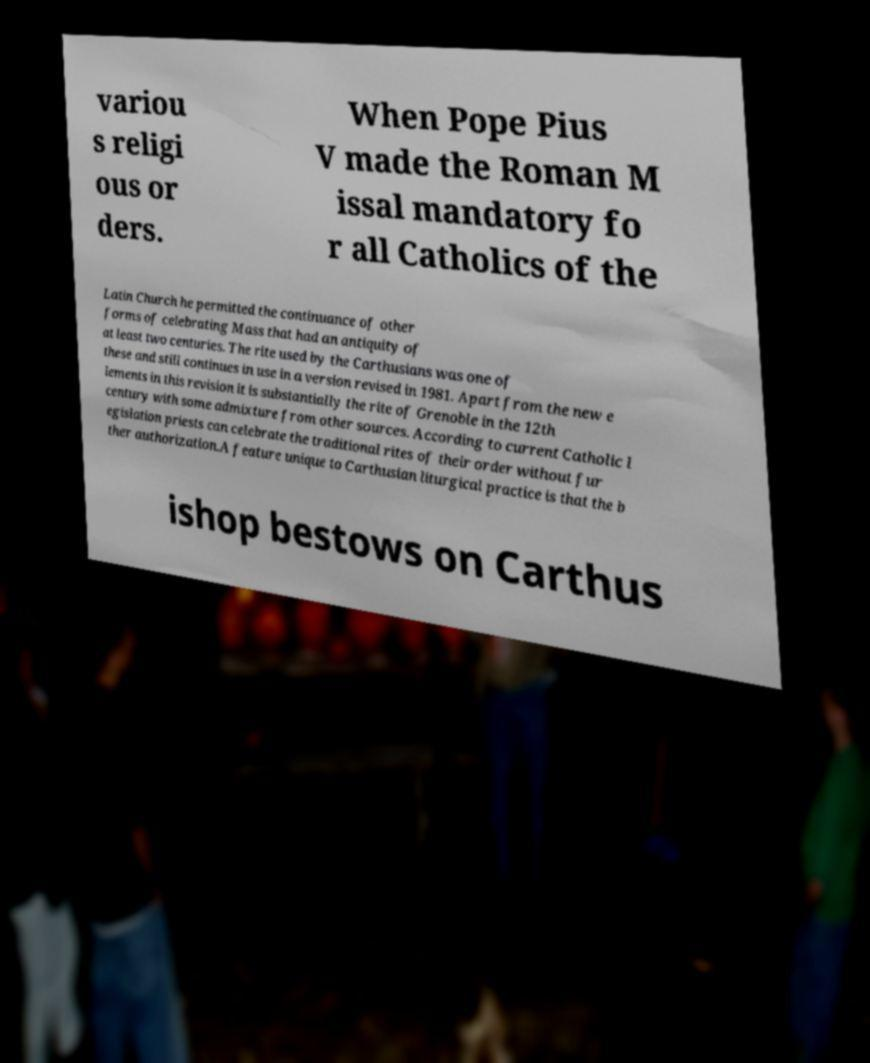What messages or text are displayed in this image? I need them in a readable, typed format. variou s religi ous or ders. When Pope Pius V made the Roman M issal mandatory fo r all Catholics of the Latin Church he permitted the continuance of other forms of celebrating Mass that had an antiquity of at least two centuries. The rite used by the Carthusians was one of these and still continues in use in a version revised in 1981. Apart from the new e lements in this revision it is substantially the rite of Grenoble in the 12th century with some admixture from other sources. According to current Catholic l egislation priests can celebrate the traditional rites of their order without fur ther authorization.A feature unique to Carthusian liturgical practice is that the b ishop bestows on Carthus 